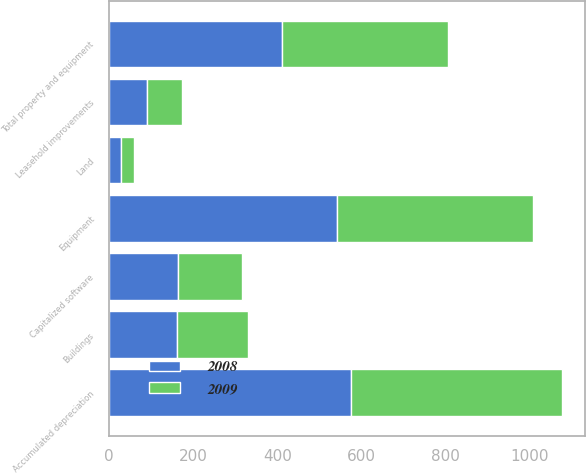<chart> <loc_0><loc_0><loc_500><loc_500><stacked_bar_chart><ecel><fcel>Land<fcel>Buildings<fcel>Equipment<fcel>Capitalized software<fcel>Leasehold improvements<fcel>Total property and equipment<fcel>Accumulated depreciation<nl><fcel>2008<fcel>29<fcel>162<fcel>541<fcel>164<fcel>90<fcel>411<fcel>575<nl><fcel>2009<fcel>29<fcel>169<fcel>466<fcel>151<fcel>82<fcel>395<fcel>502<nl></chart> 